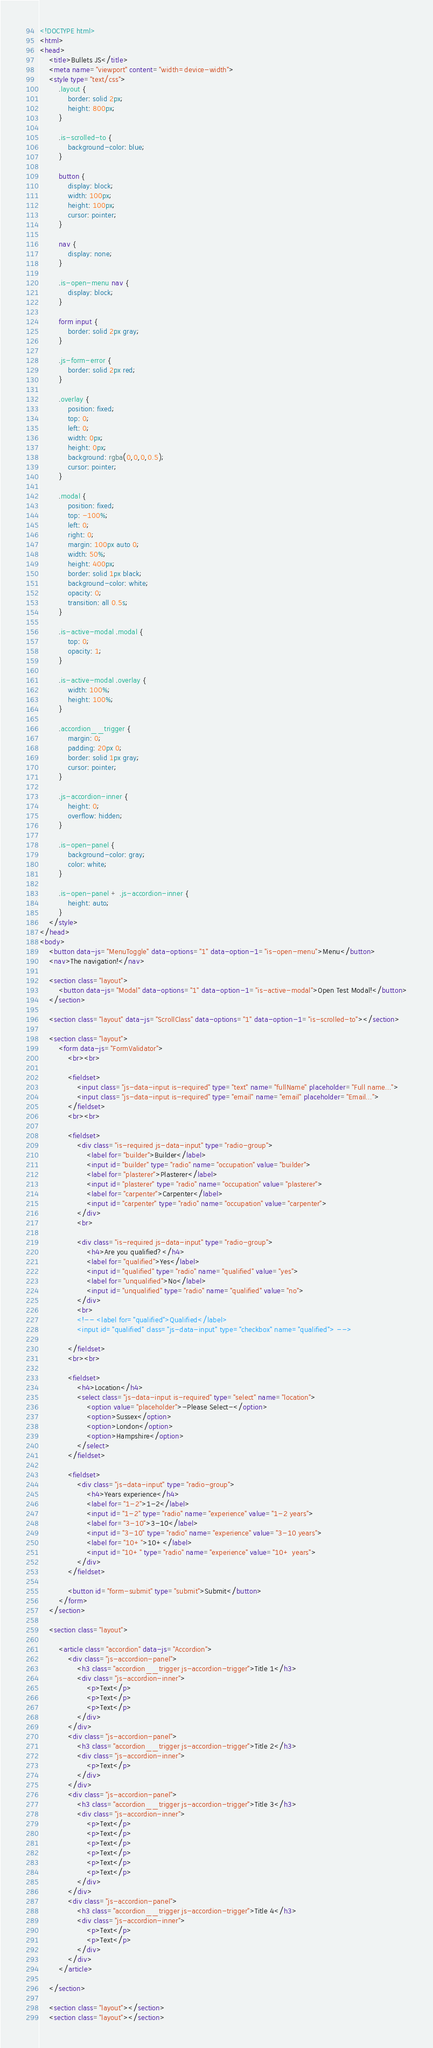Convert code to text. <code><loc_0><loc_0><loc_500><loc_500><_HTML_><!DOCTYPE html>
<html>
<head>
	<title>Bullets JS</title>
	<meta name="viewport" content="width=device-width">
	<style type="text/css">
		.layout {
			border: solid 2px;
			height: 800px;
		}

		.is-scrolled-to {
			background-color: blue;
		}

		button {
			display: block;
			width: 100px;
			height: 100px;
			cursor: pointer;
		}

		nav {
			display: none;
		}

		.is-open-menu nav {
			display: block;
		}

		form input {
			border: solid 2px gray;
		}

		.js-form-error {
			border: solid 2px red;
		}

		.overlay {
			position: fixed;
			top: 0;
			left: 0;
			width: 0px;
			height: 0px;
			background: rgba(0,0,0,0.5);
			cursor: pointer;
		}

		.modal {
			position: fixed;
			top: -100%;
			left: 0;
			right: 0;
			margin: 100px auto 0;
			width: 50%;
			height: 400px;
			border: solid 1px black;
			background-color: white;
			opacity: 0;
			transition: all 0.5s;
		}

		.is-active-modal .modal {
			top: 0;
			opacity: 1;
		}

		.is-active-modal .overlay {
			width: 100%;
			height: 100%;
		}

		.accordion__trigger {
			margin: 0;
			padding: 20px 0;
			border: solid 1px gray;
			cursor: pointer;
		}

		.js-accordion-inner {
			height: 0;
			overflow: hidden;
		}

		.is-open-panel {
			background-color: gray;
			color: white;
		}

		.is-open-panel + .js-accordion-inner {
			height: auto;
		}
	</style>
</head>
<body>
	<button data-js="MenuToggle" data-options="1" data-option-1="is-open-menu">Menu</button>
	<nav>The navigation!</nav>

	<section class="layout">
		<button data-js="Modal" data-options="1" data-option-1="is-active-modal">Open Test Modal!</button>
	</section>

	<section class="layout" data-js="ScrollClass" data-options="1" data-option-1="is-scrolled-to"></section>

	<section class="layout">
		<form data-js="FormValidator">
			<br><br>

			<fieldset>
				<input class="js-data-input is-required" type="text" name="fullName" placeholder="Full name...">
				<input class="js-data-input is-required" type="email" name="email" placeholder="Email...">
			</fieldset>
			<br><br>

			<fieldset>
				<div class="is-required js-data-input" type="radio-group">
					<label for="builder">Builder</label>
					<input id="builder" type="radio" name="occupation" value="builder">
					<label for="plasterer">Plasterer</label>
					<input id="plasterer" type="radio" name="occupation" value="plasterer">
					<label for="carpenter">Carpenter</label>
					<input id="carpenter" type="radio" name="occupation" value="carpenter">
				</div>
				<br>

				<div class="is-required js-data-input" type="radio-group">
					<h4>Are you qualified?</h4>
					<label for="qualified">Yes</label>
					<input id="qualified" type="radio" name="qualified" value="yes">
					<label for="unqualified">No</label>
					<input id="unqualified" type="radio" name="qualified" value="no">
				</div>
				<br>
				<!-- <label for="qualified">Qualified</label>
				<input id="qualified" class="js-data-input" type="checkbox" name="qualified"> -->

			</fieldset>
			<br><br>

			<fieldset>
				<h4>Location</h4>
				<select class="js-data-input is-required" type="select" name="location">
					<option value="placeholder">-Please Select-</option>
					<option>Sussex</option>
					<option>London</option>
					<option>Hampshire</option>
				</select>
			</fieldset>

			<fieldset>
				<div class="js-data-input" type="radio-group">
					<h4>Years experience</h4>
					<label for="1-2">1-2</label>
					<input id="1-2" type="radio" name="experience" value="1-2 years">
					<label for="3-10">3-10</label>
					<input id="3-10" type="radio" name="experience" value="3-10 years">
					<label for="10+">10+</label>
					<input id="10+" type="radio" name="experience" value="10+ years">
				</div>
			</fieldset>
			
			<button id="form-submit" type="submit">Submit</button>
		</form>
	</section>

	<section class="layout">

		<article class="accordion" data-js="Accordion">
			<div class="js-accordion-panel">
				<h3 class="accordion__trigger js-accordion-trigger">Title 1</h3>
				<div class="js-accordion-inner">
					<p>Text</p>
					<p>Text</p>
					<p>Text</p>
				</div>
			</div>
			<div class="js-accordion-panel">
				<h3 class="accordion__trigger js-accordion-trigger">Title 2</h3>
				<div class="js-accordion-inner">
					<p>Text</p>
				</div>
			</div>
			<div class="js-accordion-panel">
				<h3 class="accordion__trigger js-accordion-trigger">Title 3</h3>
				<div class="js-accordion-inner">
					<p>Text</p>
					<p>Text</p>
					<p>Text</p>
					<p>Text</p>
					<p>Text</p>
					<p>Text</p>
				</div>
			</div>
			<div class="js-accordion-panel">
				<h3 class="accordion__trigger js-accordion-trigger">Title 4</h3>
				<div class="js-accordion-inner">
					<p>Text</p>
					<p>Text</p>
				</div>
			</div>			
		</article>

	</section>

	<section class="layout"></section>
	<section class="layout"></section></code> 